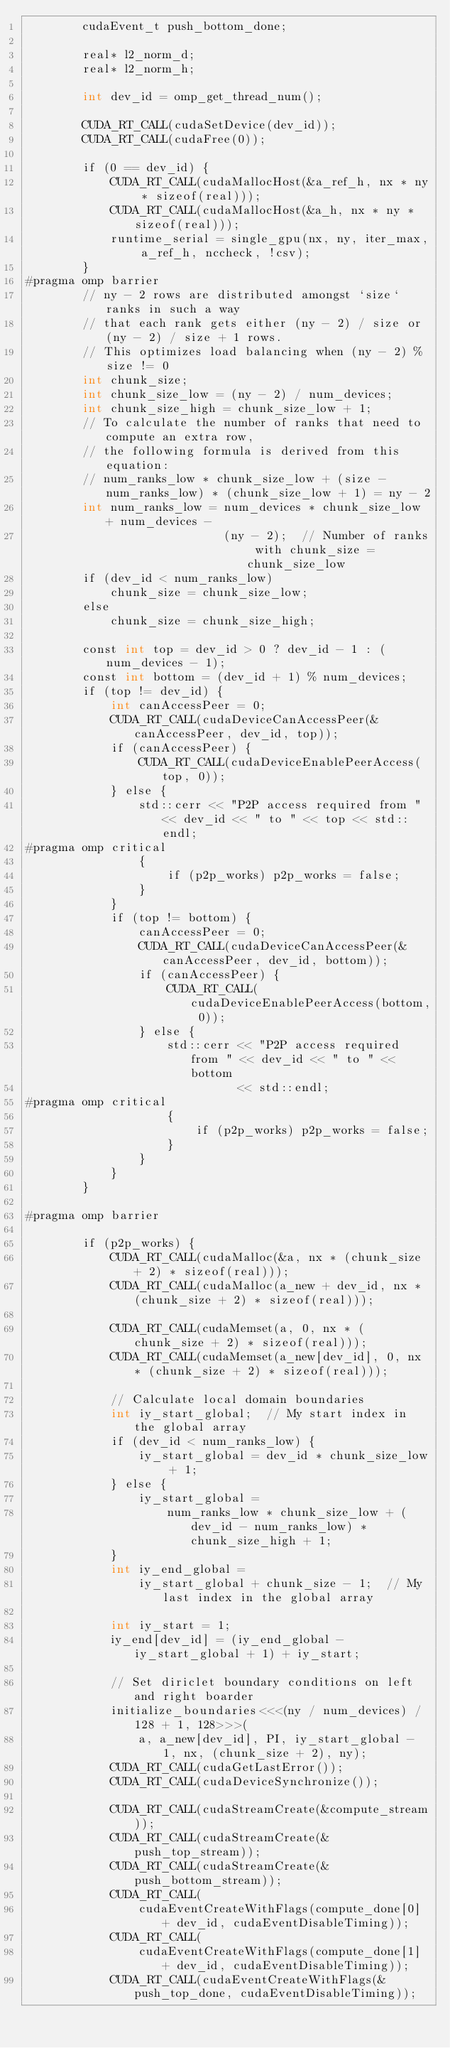Convert code to text. <code><loc_0><loc_0><loc_500><loc_500><_Cuda_>        cudaEvent_t push_bottom_done;

        real* l2_norm_d;
        real* l2_norm_h;

        int dev_id = omp_get_thread_num();

        CUDA_RT_CALL(cudaSetDevice(dev_id));
        CUDA_RT_CALL(cudaFree(0));

        if (0 == dev_id) {
            CUDA_RT_CALL(cudaMallocHost(&a_ref_h, nx * ny * sizeof(real)));
            CUDA_RT_CALL(cudaMallocHost(&a_h, nx * ny * sizeof(real)));
            runtime_serial = single_gpu(nx, ny, iter_max, a_ref_h, nccheck, !csv);
        }
#pragma omp barrier
        // ny - 2 rows are distributed amongst `size` ranks in such a way
        // that each rank gets either (ny - 2) / size or (ny - 2) / size + 1 rows.
        // This optimizes load balancing when (ny - 2) % size != 0
        int chunk_size;
        int chunk_size_low = (ny - 2) / num_devices;
        int chunk_size_high = chunk_size_low + 1;
        // To calculate the number of ranks that need to compute an extra row,
        // the following formula is derived from this equation:
        // num_ranks_low * chunk_size_low + (size - num_ranks_low) * (chunk_size_low + 1) = ny - 2
        int num_ranks_low = num_devices * chunk_size_low + num_devices -
                            (ny - 2);  // Number of ranks with chunk_size = chunk_size_low
        if (dev_id < num_ranks_low)
            chunk_size = chunk_size_low;
        else
            chunk_size = chunk_size_high;

        const int top = dev_id > 0 ? dev_id - 1 : (num_devices - 1);
        const int bottom = (dev_id + 1) % num_devices;
        if (top != dev_id) {
            int canAccessPeer = 0;
            CUDA_RT_CALL(cudaDeviceCanAccessPeer(&canAccessPeer, dev_id, top));
            if (canAccessPeer) {
                CUDA_RT_CALL(cudaDeviceEnablePeerAccess(top, 0));
            } else {
                std::cerr << "P2P access required from " << dev_id << " to " << top << std::endl;
#pragma omp critical
                {
                    if (p2p_works) p2p_works = false;
                }
            }
            if (top != bottom) {
                canAccessPeer = 0;
                CUDA_RT_CALL(cudaDeviceCanAccessPeer(&canAccessPeer, dev_id, bottom));
                if (canAccessPeer) {
                    CUDA_RT_CALL(cudaDeviceEnablePeerAccess(bottom, 0));
                } else {
                    std::cerr << "P2P access required from " << dev_id << " to " << bottom
                              << std::endl;
#pragma omp critical
                    {
                        if (p2p_works) p2p_works = false;
                    }
                }
            }
        }

#pragma omp barrier

        if (p2p_works) {
            CUDA_RT_CALL(cudaMalloc(&a, nx * (chunk_size + 2) * sizeof(real)));
            CUDA_RT_CALL(cudaMalloc(a_new + dev_id, nx * (chunk_size + 2) * sizeof(real)));

            CUDA_RT_CALL(cudaMemset(a, 0, nx * (chunk_size + 2) * sizeof(real)));
            CUDA_RT_CALL(cudaMemset(a_new[dev_id], 0, nx * (chunk_size + 2) * sizeof(real)));

            // Calculate local domain boundaries
            int iy_start_global;  // My start index in the global array
            if (dev_id < num_ranks_low) {
                iy_start_global = dev_id * chunk_size_low + 1;
            } else {
                iy_start_global =
                    num_ranks_low * chunk_size_low + (dev_id - num_ranks_low) * chunk_size_high + 1;
            }
            int iy_end_global =
                iy_start_global + chunk_size - 1;  // My last index in the global array

            int iy_start = 1;
            iy_end[dev_id] = (iy_end_global - iy_start_global + 1) + iy_start;

            // Set diriclet boundary conditions on left and right boarder
            initialize_boundaries<<<(ny / num_devices) / 128 + 1, 128>>>(
                a, a_new[dev_id], PI, iy_start_global - 1, nx, (chunk_size + 2), ny);
            CUDA_RT_CALL(cudaGetLastError());
            CUDA_RT_CALL(cudaDeviceSynchronize());

            CUDA_RT_CALL(cudaStreamCreate(&compute_stream));
            CUDA_RT_CALL(cudaStreamCreate(&push_top_stream));
            CUDA_RT_CALL(cudaStreamCreate(&push_bottom_stream));
            CUDA_RT_CALL(
                cudaEventCreateWithFlags(compute_done[0] + dev_id, cudaEventDisableTiming));
            CUDA_RT_CALL(
                cudaEventCreateWithFlags(compute_done[1] + dev_id, cudaEventDisableTiming));
            CUDA_RT_CALL(cudaEventCreateWithFlags(&push_top_done, cudaEventDisableTiming));</code> 